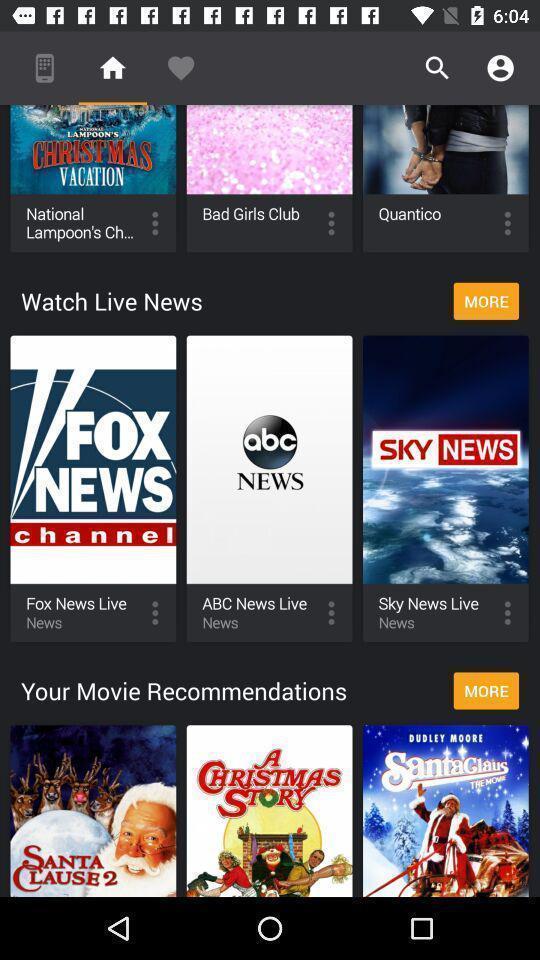Tell me about the visual elements in this screen capture. Page displaying various categories in streaming app. 